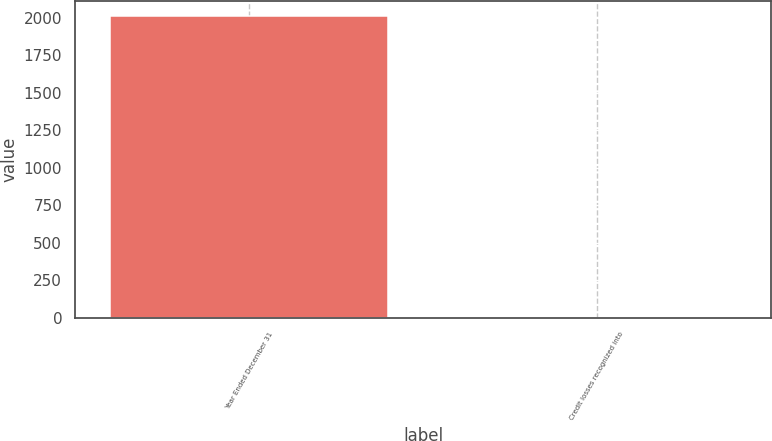<chart> <loc_0><loc_0><loc_500><loc_500><bar_chart><fcel>Year Ended December 31<fcel>Credit losses recognized into<nl><fcel>2013<fcel>1<nl></chart> 